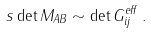<formula> <loc_0><loc_0><loc_500><loc_500>s \det M _ { A B } \sim \det G ^ { e f f } _ { i j } \, .</formula> 